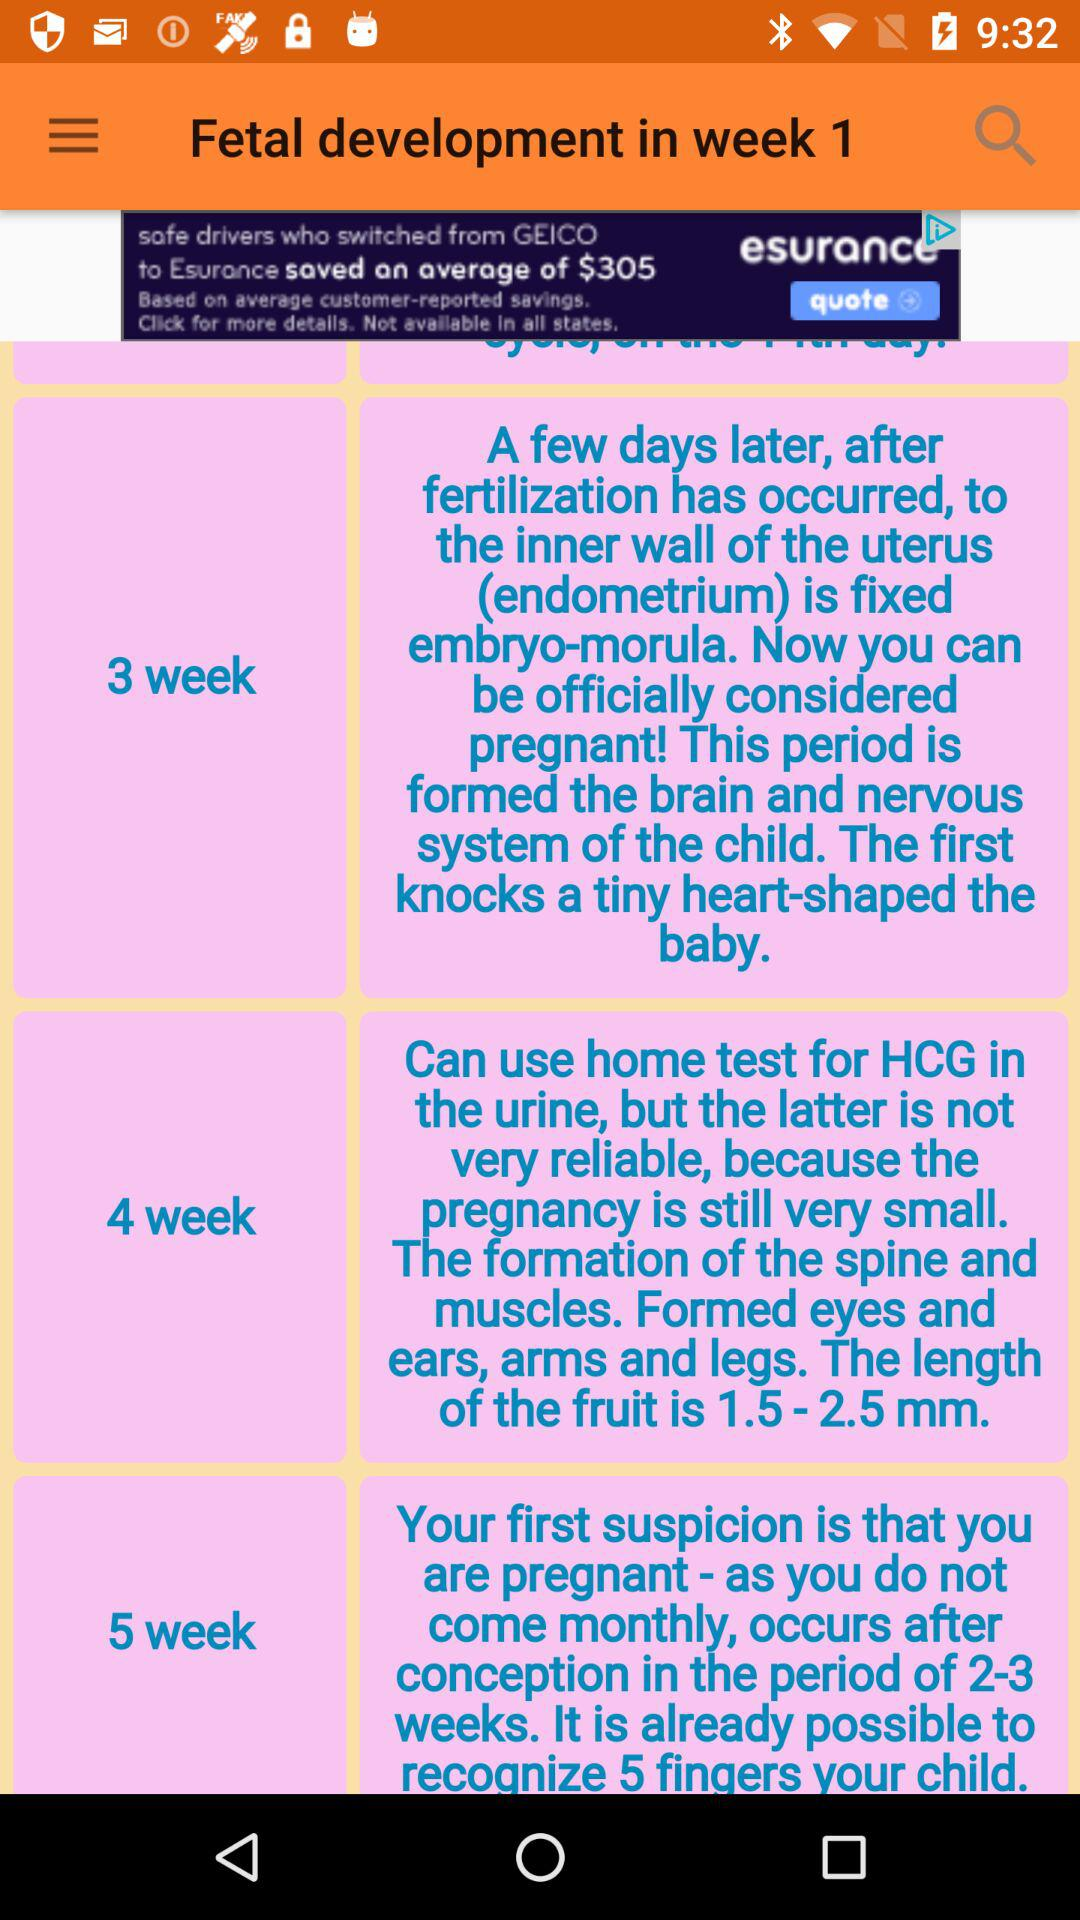How many more weeks are there between week 1 and week 5?
Answer the question using a single word or phrase. 4 